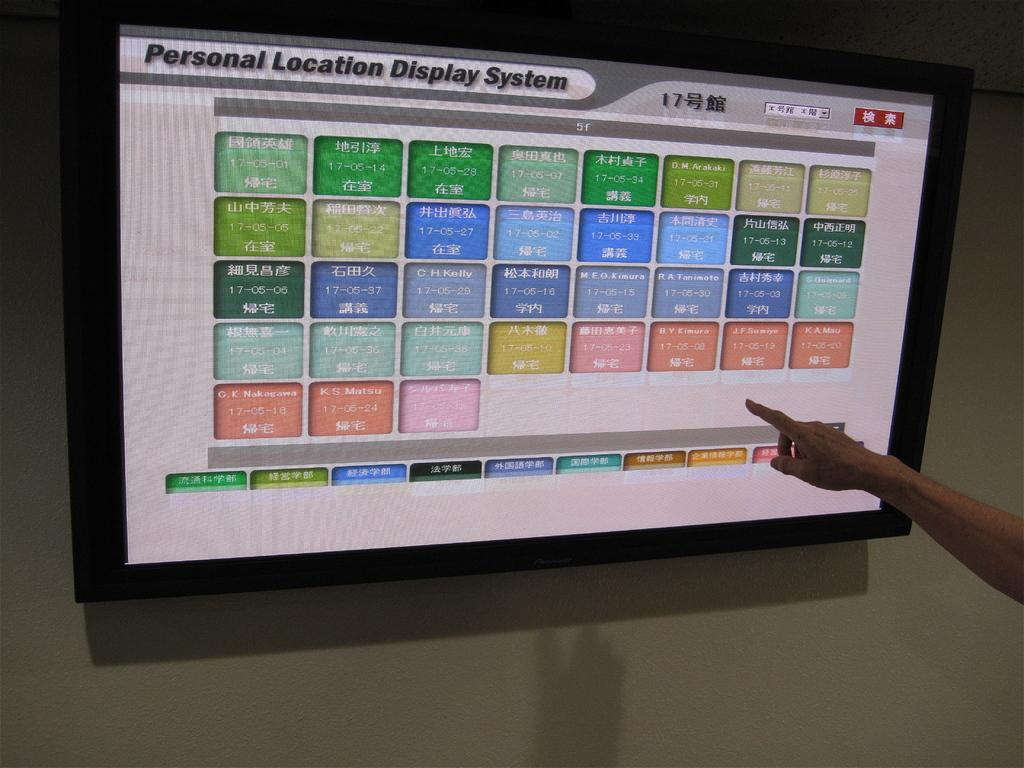<image>
Describe the image concisely. A monitor displays a personal location display system. 